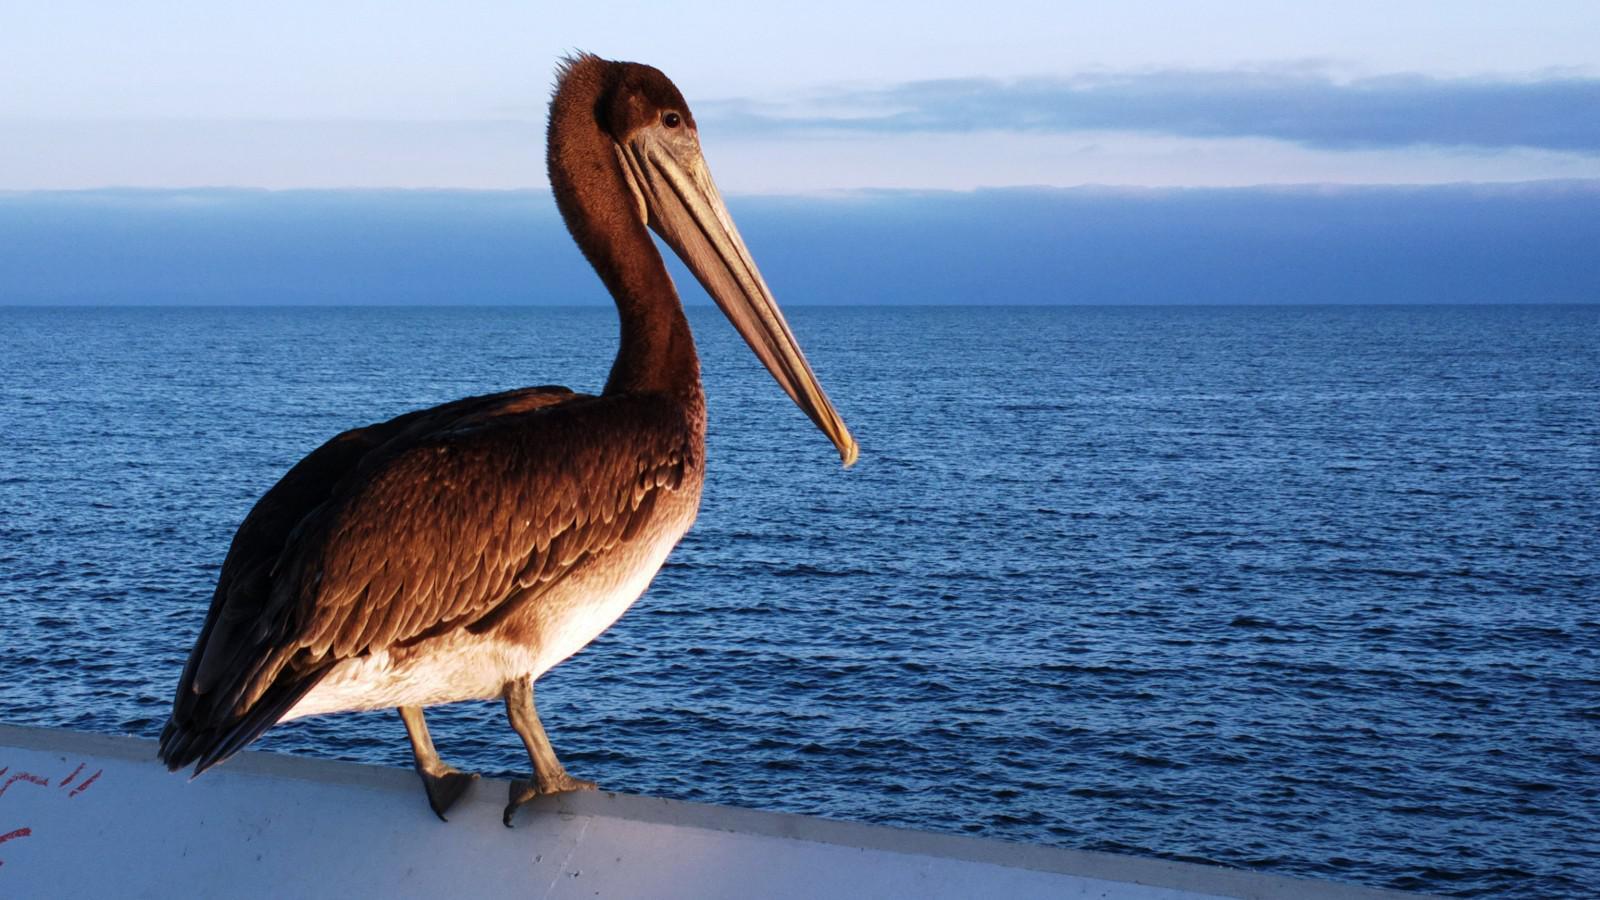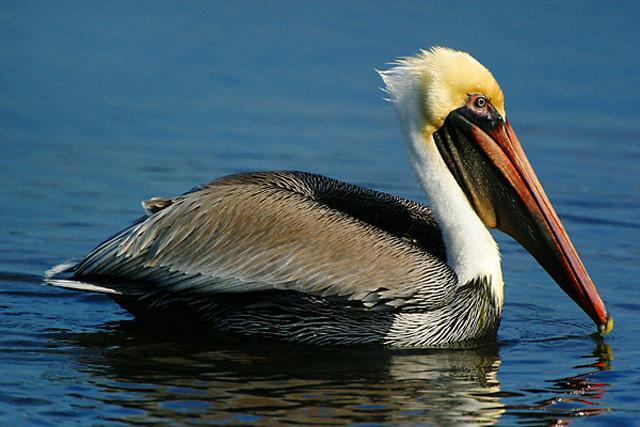The first image is the image on the left, the second image is the image on the right. Assess this claim about the two images: "In one of the images, there is a pelican in flight". Correct or not? Answer yes or no. No. 